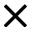Convert formula to latex. <formula><loc_0><loc_0><loc_500><loc_500>\times</formula> 